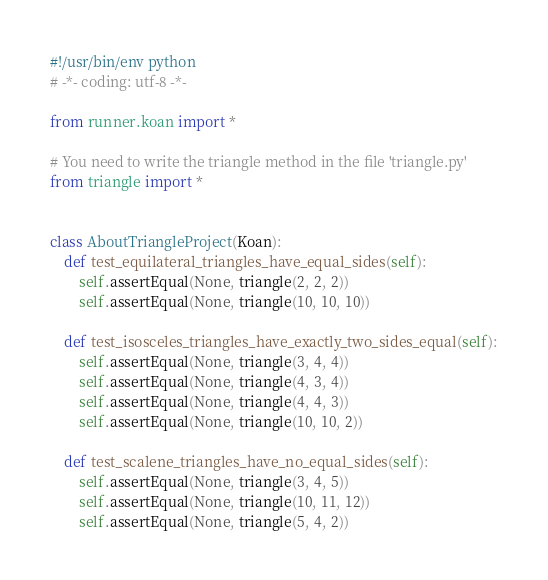Convert code to text. <code><loc_0><loc_0><loc_500><loc_500><_Python_>#!/usr/bin/env python
# -*- coding: utf-8 -*-

from runner.koan import *

# You need to write the triangle method in the file 'triangle.py'
from triangle import *


class AboutTriangleProject(Koan):
    def test_equilateral_triangles_have_equal_sides(self):
        self.assertEqual(None, triangle(2, 2, 2))
        self.assertEqual(None, triangle(10, 10, 10))

    def test_isosceles_triangles_have_exactly_two_sides_equal(self):
        self.assertEqual(None, triangle(3, 4, 4))
        self.assertEqual(None, triangle(4, 3, 4))
        self.assertEqual(None, triangle(4, 4, 3))
        self.assertEqual(None, triangle(10, 10, 2))

    def test_scalene_triangles_have_no_equal_sides(self):
        self.assertEqual(None, triangle(3, 4, 5))
        self.assertEqual(None, triangle(10, 11, 12))
        self.assertEqual(None, triangle(5, 4, 2))
</code> 